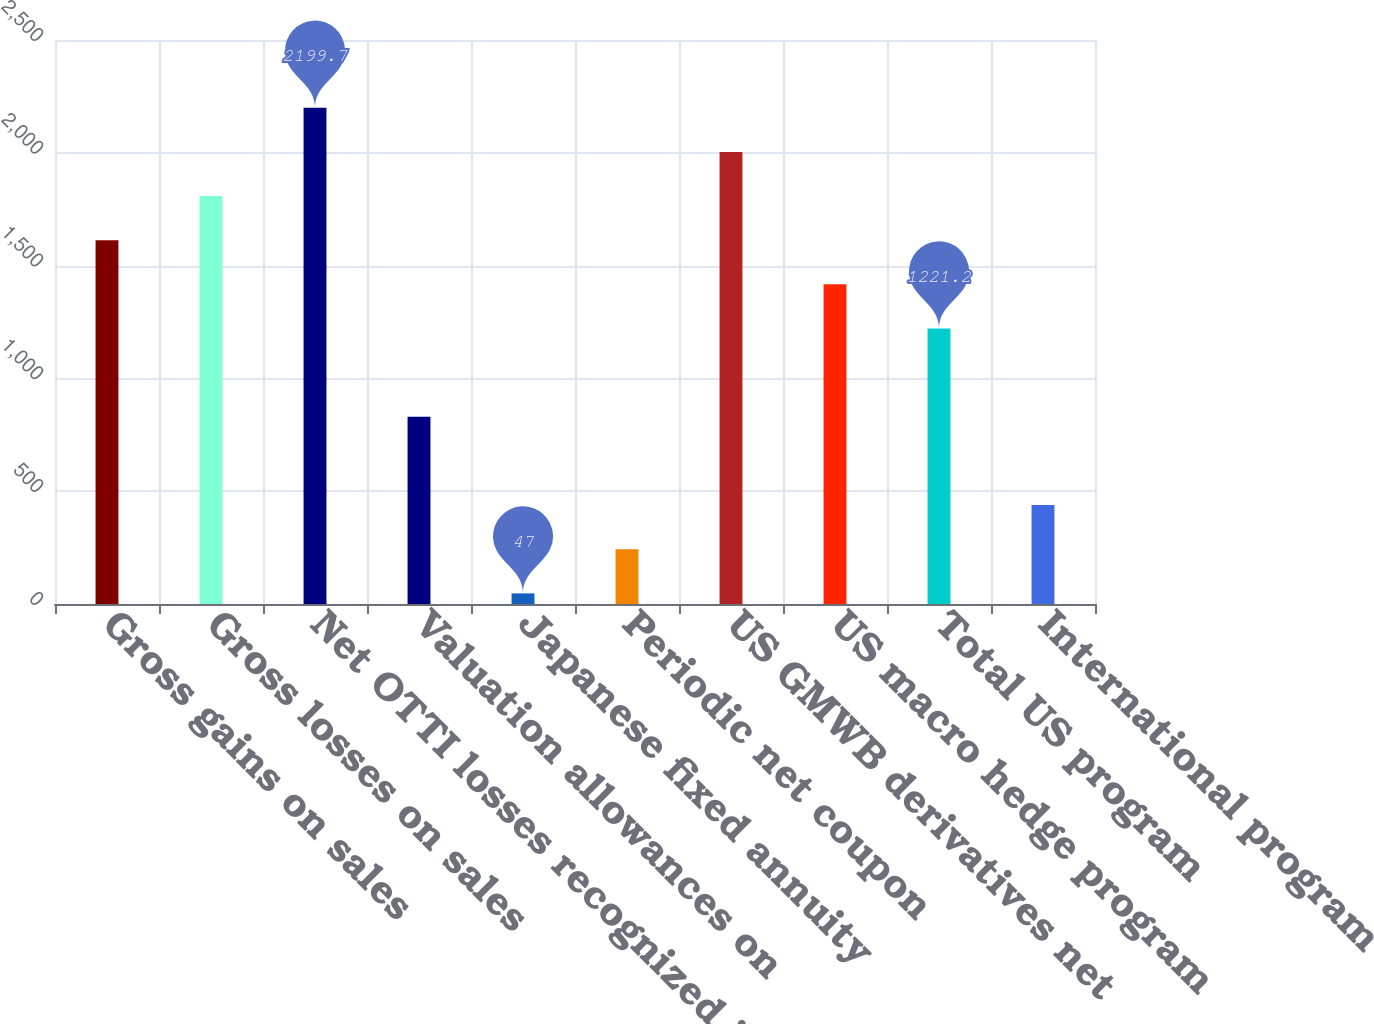<chart> <loc_0><loc_0><loc_500><loc_500><bar_chart><fcel>Gross gains on sales<fcel>Gross losses on sales<fcel>Net OTTI losses recognized in<fcel>Valuation allowances on<fcel>Japanese fixed annuity<fcel>Periodic net coupon<fcel>US GMWB derivatives net<fcel>US macro hedge program<fcel>Total US program<fcel>International program<nl><fcel>1612.6<fcel>1808.3<fcel>2199.7<fcel>829.8<fcel>47<fcel>242.7<fcel>2004<fcel>1416.9<fcel>1221.2<fcel>438.4<nl></chart> 